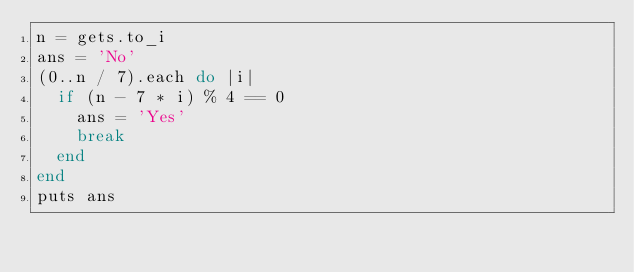<code> <loc_0><loc_0><loc_500><loc_500><_Ruby_>n = gets.to_i
ans = 'No'
(0..n / 7).each do |i|
  if (n - 7 * i) % 4 == 0
    ans = 'Yes'
    break
  end
end
puts ans</code> 